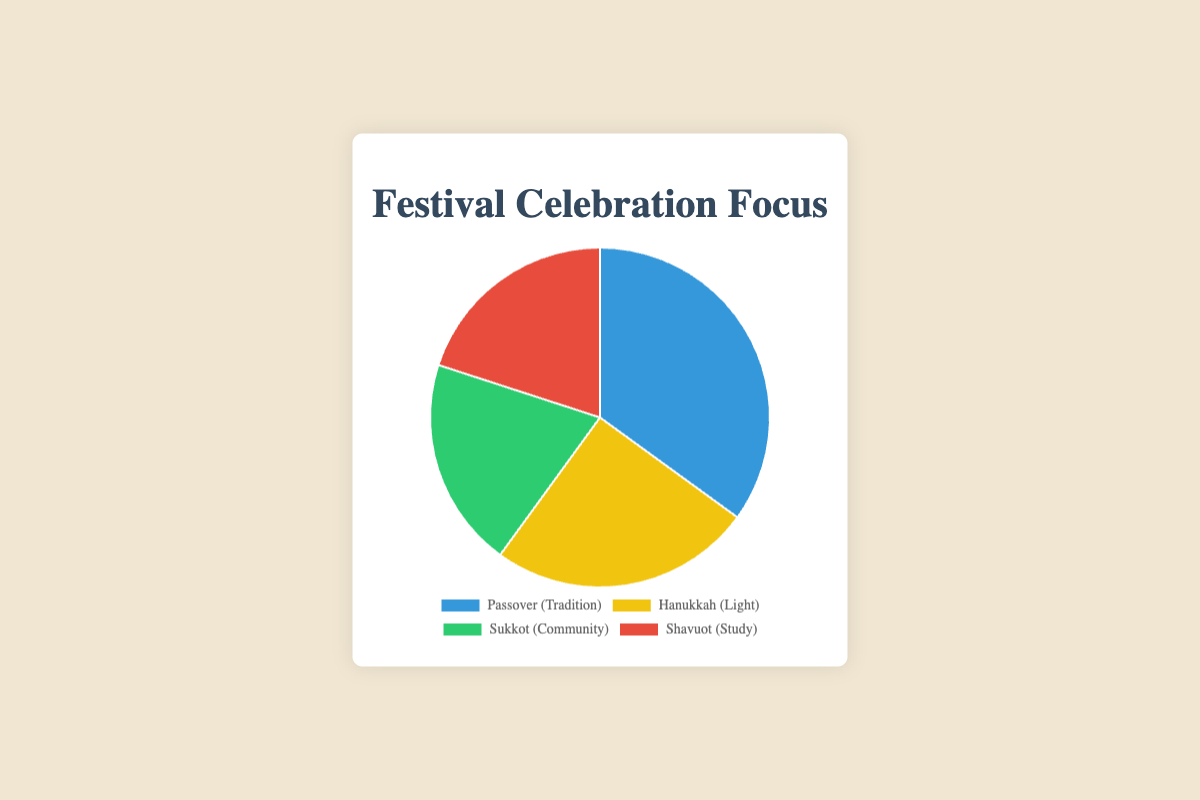What is the percentage focus on Shavuot? The pie chart shows the percentage for each festival. Shavuot has a label indicating a 20% focus on "Study."
Answer: 20% Which festival has the highest percentage focus? The pie chart shows four festivals with their respective percentages. Passover has the highest percentage focus at 35%, which is indicated by the size of its segment and its label.
Answer: Passover How does the focus on Hanukkah compare to the focus on Sukkot? The pie chart shows Hanukkah at 25% and Sukkot at 20%. To compare, note that 25% is greater than 20%.
Answer: Hanukkah has a higher focus What is the combined percentage focus of Sukkot and Shavuot? The pie chart shows Sukkot at 20% and Shavuot at 20%. Adding these together, 20% + 20% = 40%.
Answer: 40% Which festival's focus is represented by the green segment? The green segment in the pie chart is labeled with "Sukkot (Community)" at 20%.
Answer: Sukkot What percentage of focus is tradition if summed with the focus on light? The pie chart indicates Passover (Tradition) at 35% and Hanukkah (Light) at 25%. Adding these together, 35% + 25% = 60%.
Answer: 60% Are there any festivals with an equal percentage focus? The pie chart shows Sukkot at 20% and Shavuot at 20%. They have equal percentages.
Answer: Yes, Sukkot and Shavuot By what percentage does the focus on Tradition exceed that of Community? The pie chart shows Tradition (Passover) at 35% and Community (Sukkot) at 20%. Subtracting these, 35% - 20% = 15%.
Answer: 15% 